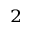<formula> <loc_0><loc_0><loc_500><loc_500>^ { 2 }</formula> 